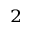<formula> <loc_0><loc_0><loc_500><loc_500>^ { 2 }</formula> 